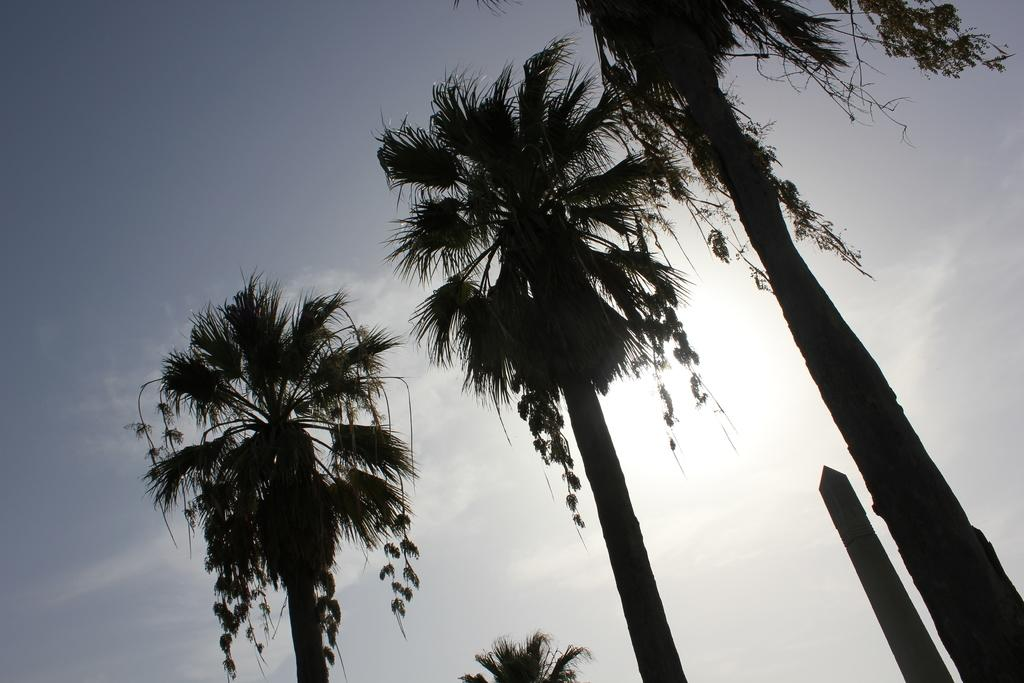What type of vegetation is visible in the image? There are many trees in the image. What can be seen in the sky at the top of the image? There are clouds in the sky at the top of the image. How much money is being exchanged between the trees in the image? There is no money being exchanged in the image; it features trees and clouds. What type of sock is hanging on the tree in the image? There is no sock present in the image; it only features trees and clouds. 